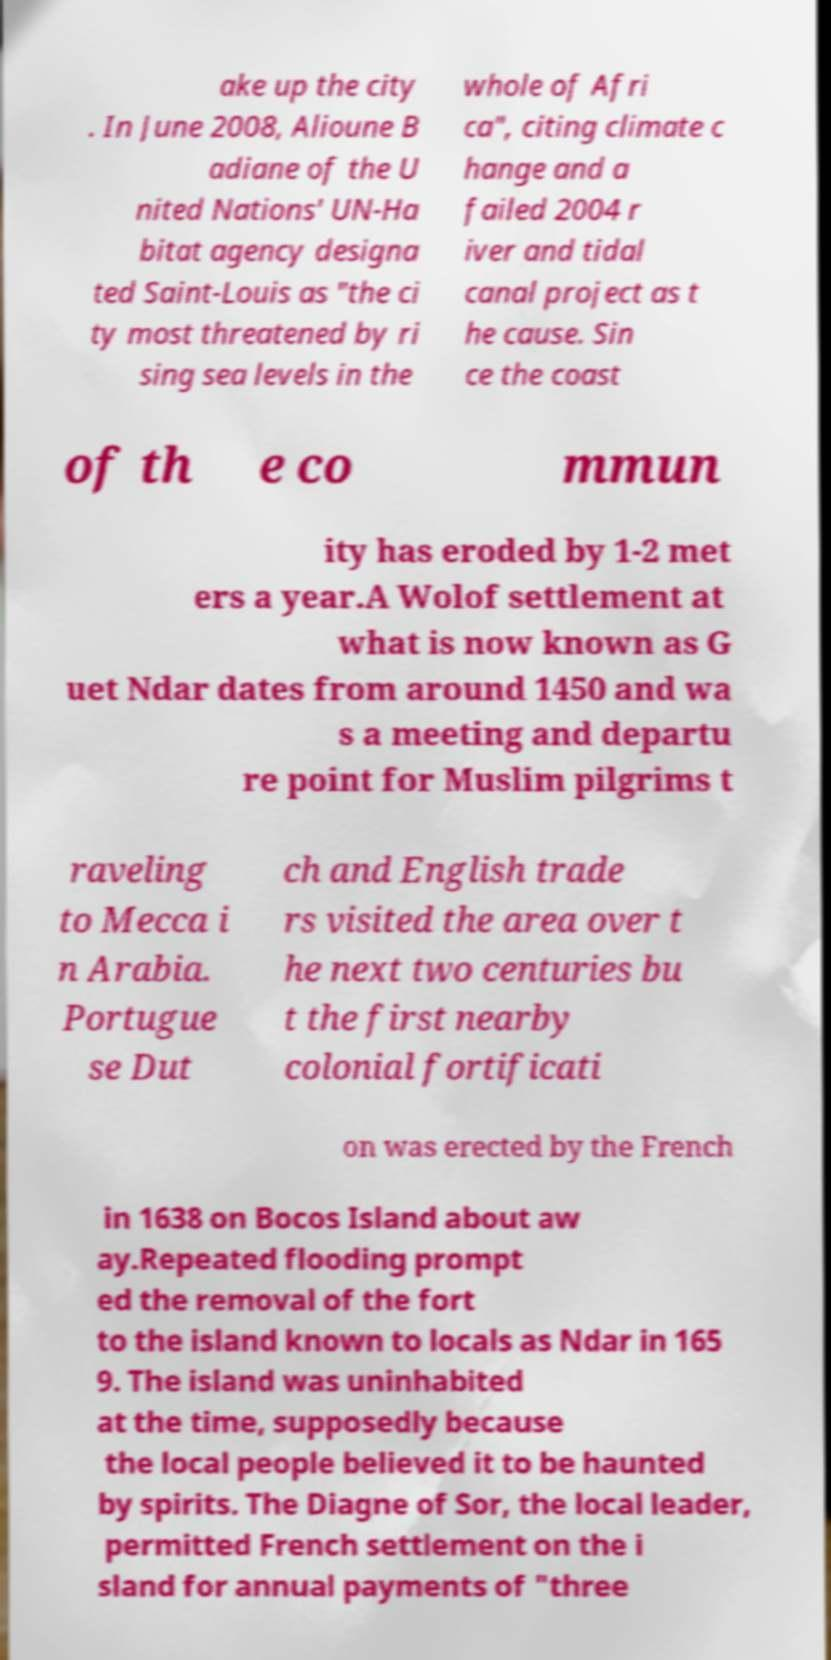What messages or text are displayed in this image? I need them in a readable, typed format. ake up the city . In June 2008, Alioune B adiane of the U nited Nations' UN-Ha bitat agency designa ted Saint-Louis as "the ci ty most threatened by ri sing sea levels in the whole of Afri ca", citing climate c hange and a failed 2004 r iver and tidal canal project as t he cause. Sin ce the coast of th e co mmun ity has eroded by 1-2 met ers a year.A Wolof settlement at what is now known as G uet Ndar dates from around 1450 and wa s a meeting and departu re point for Muslim pilgrims t raveling to Mecca i n Arabia. Portugue se Dut ch and English trade rs visited the area over t he next two centuries bu t the first nearby colonial fortificati on was erected by the French in 1638 on Bocos Island about aw ay.Repeated flooding prompt ed the removal of the fort to the island known to locals as Ndar in 165 9. The island was uninhabited at the time, supposedly because the local people believed it to be haunted by spirits. The Diagne of Sor, the local leader, permitted French settlement on the i sland for annual payments of "three 